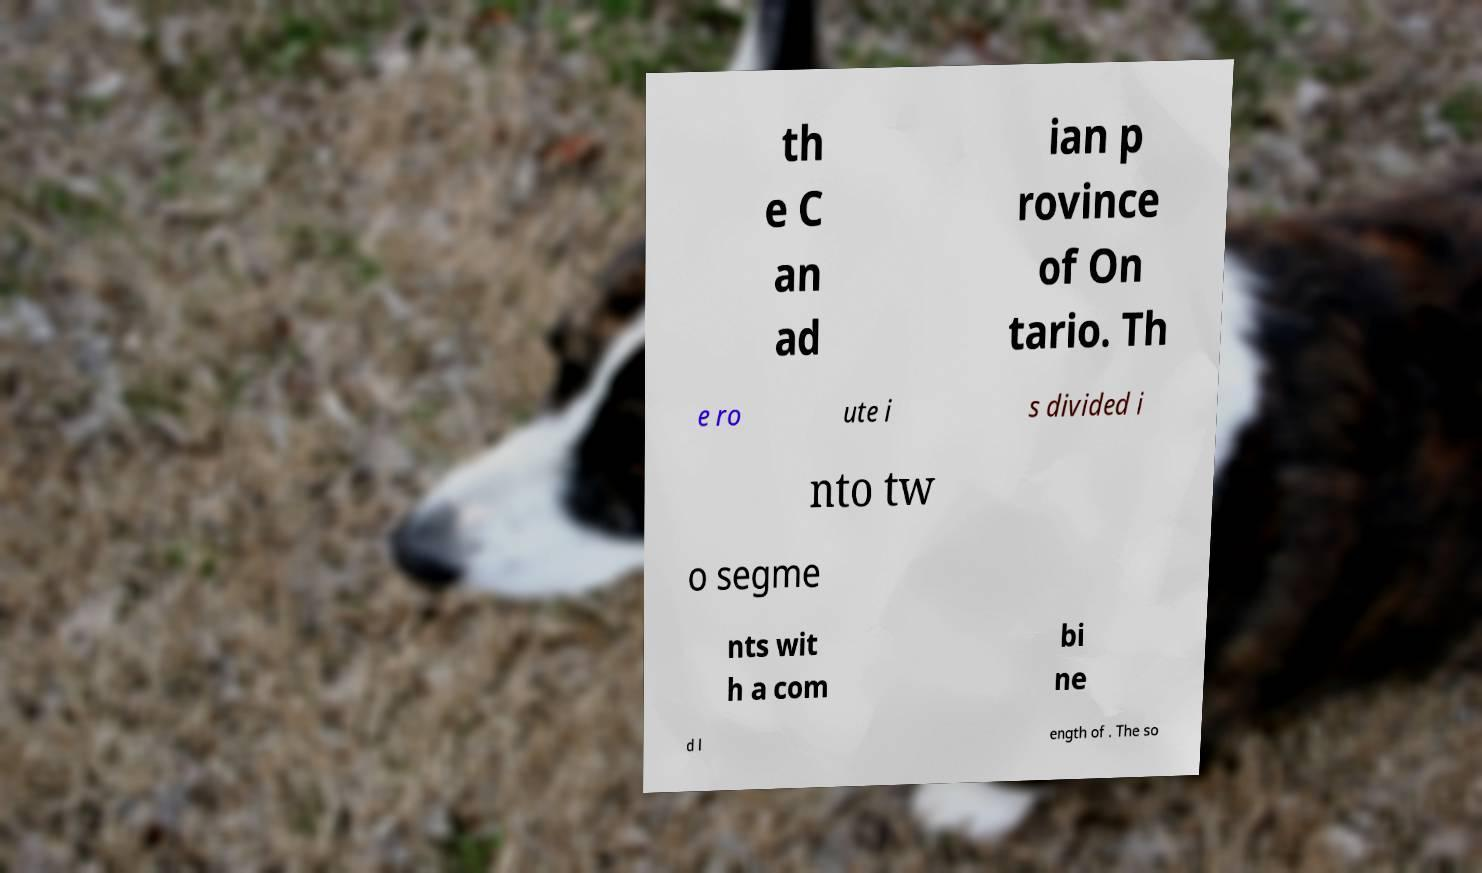Can you read and provide the text displayed in the image?This photo seems to have some interesting text. Can you extract and type it out for me? th e C an ad ian p rovince of On tario. Th e ro ute i s divided i nto tw o segme nts wit h a com bi ne d l ength of . The so 